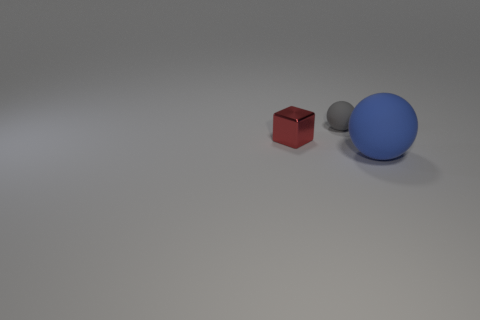Can you describe the atmosphere or mood conveyed by the image? The image has a minimalist and clean atmosphere, giving a sense of calm and order. The stark contrasts and simple geometrical shapes contribute to a tranquil, almost sterile scene. 